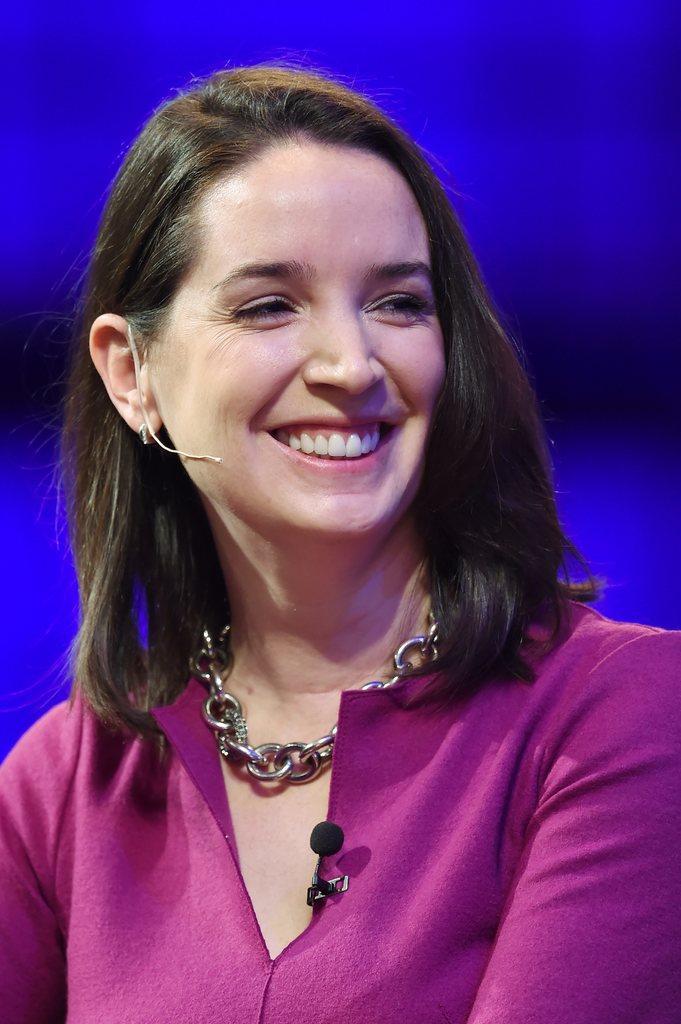Please provide a concise description of this image. In this image we can see a woman smiling. 